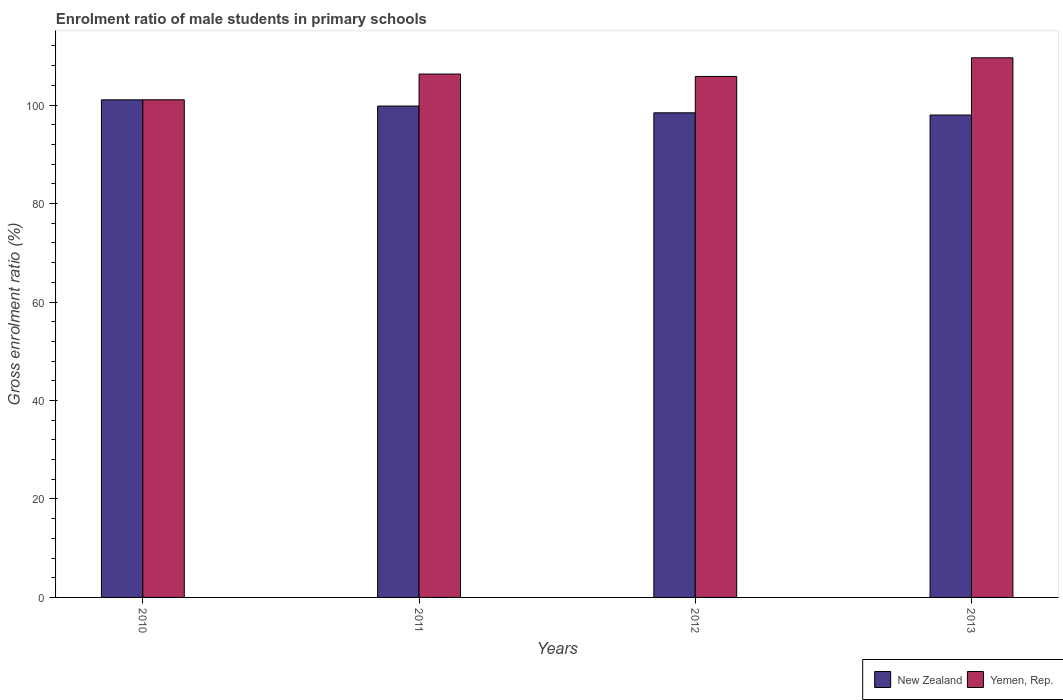How many groups of bars are there?
Offer a very short reply. 4. Are the number of bars per tick equal to the number of legend labels?
Your response must be concise. Yes. Are the number of bars on each tick of the X-axis equal?
Your answer should be very brief. Yes. How many bars are there on the 1st tick from the left?
Provide a short and direct response. 2. What is the label of the 2nd group of bars from the left?
Make the answer very short. 2011. In how many cases, is the number of bars for a given year not equal to the number of legend labels?
Keep it short and to the point. 0. What is the enrolment ratio of male students in primary schools in New Zealand in 2013?
Your answer should be compact. 97.98. Across all years, what is the maximum enrolment ratio of male students in primary schools in New Zealand?
Your answer should be compact. 101.06. Across all years, what is the minimum enrolment ratio of male students in primary schools in Yemen, Rep.?
Make the answer very short. 101.07. What is the total enrolment ratio of male students in primary schools in New Zealand in the graph?
Keep it short and to the point. 397.27. What is the difference between the enrolment ratio of male students in primary schools in New Zealand in 2011 and that in 2012?
Ensure brevity in your answer.  1.38. What is the difference between the enrolment ratio of male students in primary schools in New Zealand in 2011 and the enrolment ratio of male students in primary schools in Yemen, Rep. in 2012?
Keep it short and to the point. -6.01. What is the average enrolment ratio of male students in primary schools in New Zealand per year?
Your response must be concise. 99.32. In the year 2012, what is the difference between the enrolment ratio of male students in primary schools in New Zealand and enrolment ratio of male students in primary schools in Yemen, Rep.?
Offer a terse response. -7.39. What is the ratio of the enrolment ratio of male students in primary schools in Yemen, Rep. in 2011 to that in 2013?
Your answer should be compact. 0.97. Is the enrolment ratio of male students in primary schools in New Zealand in 2010 less than that in 2011?
Provide a succinct answer. No. What is the difference between the highest and the second highest enrolment ratio of male students in primary schools in Yemen, Rep.?
Make the answer very short. 3.3. What is the difference between the highest and the lowest enrolment ratio of male students in primary schools in Yemen, Rep.?
Keep it short and to the point. 8.53. Is the sum of the enrolment ratio of male students in primary schools in New Zealand in 2010 and 2012 greater than the maximum enrolment ratio of male students in primary schools in Yemen, Rep. across all years?
Your answer should be compact. Yes. What does the 1st bar from the left in 2011 represents?
Give a very brief answer. New Zealand. What does the 1st bar from the right in 2010 represents?
Keep it short and to the point. Yemen, Rep. How many bars are there?
Provide a succinct answer. 8. How many years are there in the graph?
Keep it short and to the point. 4. What is the difference between two consecutive major ticks on the Y-axis?
Your response must be concise. 20. Does the graph contain grids?
Keep it short and to the point. No. Where does the legend appear in the graph?
Keep it short and to the point. Bottom right. How many legend labels are there?
Give a very brief answer. 2. What is the title of the graph?
Make the answer very short. Enrolment ratio of male students in primary schools. Does "Cayman Islands" appear as one of the legend labels in the graph?
Provide a succinct answer. No. What is the Gross enrolment ratio (%) of New Zealand in 2010?
Make the answer very short. 101.06. What is the Gross enrolment ratio (%) in Yemen, Rep. in 2010?
Provide a succinct answer. 101.07. What is the Gross enrolment ratio (%) in New Zealand in 2011?
Make the answer very short. 99.8. What is the Gross enrolment ratio (%) in Yemen, Rep. in 2011?
Provide a short and direct response. 106.3. What is the Gross enrolment ratio (%) of New Zealand in 2012?
Your response must be concise. 98.43. What is the Gross enrolment ratio (%) in Yemen, Rep. in 2012?
Offer a terse response. 105.81. What is the Gross enrolment ratio (%) in New Zealand in 2013?
Make the answer very short. 97.98. What is the Gross enrolment ratio (%) of Yemen, Rep. in 2013?
Your answer should be compact. 109.6. Across all years, what is the maximum Gross enrolment ratio (%) of New Zealand?
Your answer should be very brief. 101.06. Across all years, what is the maximum Gross enrolment ratio (%) of Yemen, Rep.?
Your answer should be very brief. 109.6. Across all years, what is the minimum Gross enrolment ratio (%) in New Zealand?
Provide a short and direct response. 97.98. Across all years, what is the minimum Gross enrolment ratio (%) of Yemen, Rep.?
Your answer should be compact. 101.07. What is the total Gross enrolment ratio (%) of New Zealand in the graph?
Give a very brief answer. 397.27. What is the total Gross enrolment ratio (%) of Yemen, Rep. in the graph?
Offer a terse response. 422.78. What is the difference between the Gross enrolment ratio (%) in New Zealand in 2010 and that in 2011?
Your answer should be very brief. 1.26. What is the difference between the Gross enrolment ratio (%) of Yemen, Rep. in 2010 and that in 2011?
Give a very brief answer. -5.23. What is the difference between the Gross enrolment ratio (%) in New Zealand in 2010 and that in 2012?
Ensure brevity in your answer.  2.63. What is the difference between the Gross enrolment ratio (%) in Yemen, Rep. in 2010 and that in 2012?
Your response must be concise. -4.74. What is the difference between the Gross enrolment ratio (%) in New Zealand in 2010 and that in 2013?
Your answer should be compact. 3.08. What is the difference between the Gross enrolment ratio (%) in Yemen, Rep. in 2010 and that in 2013?
Keep it short and to the point. -8.53. What is the difference between the Gross enrolment ratio (%) of New Zealand in 2011 and that in 2012?
Your answer should be very brief. 1.38. What is the difference between the Gross enrolment ratio (%) of Yemen, Rep. in 2011 and that in 2012?
Your answer should be compact. 0.49. What is the difference between the Gross enrolment ratio (%) of New Zealand in 2011 and that in 2013?
Your answer should be very brief. 1.83. What is the difference between the Gross enrolment ratio (%) of Yemen, Rep. in 2011 and that in 2013?
Give a very brief answer. -3.3. What is the difference between the Gross enrolment ratio (%) of New Zealand in 2012 and that in 2013?
Provide a succinct answer. 0.45. What is the difference between the Gross enrolment ratio (%) in Yemen, Rep. in 2012 and that in 2013?
Offer a very short reply. -3.79. What is the difference between the Gross enrolment ratio (%) of New Zealand in 2010 and the Gross enrolment ratio (%) of Yemen, Rep. in 2011?
Offer a very short reply. -5.24. What is the difference between the Gross enrolment ratio (%) of New Zealand in 2010 and the Gross enrolment ratio (%) of Yemen, Rep. in 2012?
Your answer should be compact. -4.75. What is the difference between the Gross enrolment ratio (%) of New Zealand in 2010 and the Gross enrolment ratio (%) of Yemen, Rep. in 2013?
Provide a short and direct response. -8.54. What is the difference between the Gross enrolment ratio (%) in New Zealand in 2011 and the Gross enrolment ratio (%) in Yemen, Rep. in 2012?
Provide a short and direct response. -6.01. What is the difference between the Gross enrolment ratio (%) in New Zealand in 2011 and the Gross enrolment ratio (%) in Yemen, Rep. in 2013?
Provide a succinct answer. -9.79. What is the difference between the Gross enrolment ratio (%) of New Zealand in 2012 and the Gross enrolment ratio (%) of Yemen, Rep. in 2013?
Ensure brevity in your answer.  -11.17. What is the average Gross enrolment ratio (%) in New Zealand per year?
Your answer should be compact. 99.32. What is the average Gross enrolment ratio (%) of Yemen, Rep. per year?
Your answer should be very brief. 105.7. In the year 2010, what is the difference between the Gross enrolment ratio (%) of New Zealand and Gross enrolment ratio (%) of Yemen, Rep.?
Your response must be concise. -0.01. In the year 2011, what is the difference between the Gross enrolment ratio (%) of New Zealand and Gross enrolment ratio (%) of Yemen, Rep.?
Offer a very short reply. -6.49. In the year 2012, what is the difference between the Gross enrolment ratio (%) in New Zealand and Gross enrolment ratio (%) in Yemen, Rep.?
Your response must be concise. -7.39. In the year 2013, what is the difference between the Gross enrolment ratio (%) in New Zealand and Gross enrolment ratio (%) in Yemen, Rep.?
Ensure brevity in your answer.  -11.62. What is the ratio of the Gross enrolment ratio (%) in New Zealand in 2010 to that in 2011?
Your response must be concise. 1.01. What is the ratio of the Gross enrolment ratio (%) in Yemen, Rep. in 2010 to that in 2011?
Your response must be concise. 0.95. What is the ratio of the Gross enrolment ratio (%) in New Zealand in 2010 to that in 2012?
Provide a short and direct response. 1.03. What is the ratio of the Gross enrolment ratio (%) of Yemen, Rep. in 2010 to that in 2012?
Offer a terse response. 0.96. What is the ratio of the Gross enrolment ratio (%) of New Zealand in 2010 to that in 2013?
Provide a succinct answer. 1.03. What is the ratio of the Gross enrolment ratio (%) of Yemen, Rep. in 2010 to that in 2013?
Keep it short and to the point. 0.92. What is the ratio of the Gross enrolment ratio (%) of New Zealand in 2011 to that in 2013?
Your response must be concise. 1.02. What is the ratio of the Gross enrolment ratio (%) of Yemen, Rep. in 2011 to that in 2013?
Your answer should be compact. 0.97. What is the ratio of the Gross enrolment ratio (%) of New Zealand in 2012 to that in 2013?
Offer a very short reply. 1. What is the ratio of the Gross enrolment ratio (%) in Yemen, Rep. in 2012 to that in 2013?
Keep it short and to the point. 0.97. What is the difference between the highest and the second highest Gross enrolment ratio (%) of New Zealand?
Your answer should be very brief. 1.26. What is the difference between the highest and the second highest Gross enrolment ratio (%) in Yemen, Rep.?
Keep it short and to the point. 3.3. What is the difference between the highest and the lowest Gross enrolment ratio (%) in New Zealand?
Your answer should be compact. 3.08. What is the difference between the highest and the lowest Gross enrolment ratio (%) in Yemen, Rep.?
Provide a short and direct response. 8.53. 